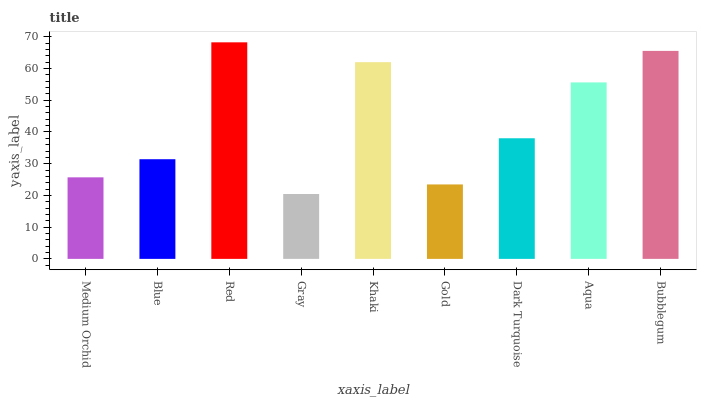Is Gray the minimum?
Answer yes or no. Yes. Is Red the maximum?
Answer yes or no. Yes. Is Blue the minimum?
Answer yes or no. No. Is Blue the maximum?
Answer yes or no. No. Is Blue greater than Medium Orchid?
Answer yes or no. Yes. Is Medium Orchid less than Blue?
Answer yes or no. Yes. Is Medium Orchid greater than Blue?
Answer yes or no. No. Is Blue less than Medium Orchid?
Answer yes or no. No. Is Dark Turquoise the high median?
Answer yes or no. Yes. Is Dark Turquoise the low median?
Answer yes or no. Yes. Is Red the high median?
Answer yes or no. No. Is Bubblegum the low median?
Answer yes or no. No. 